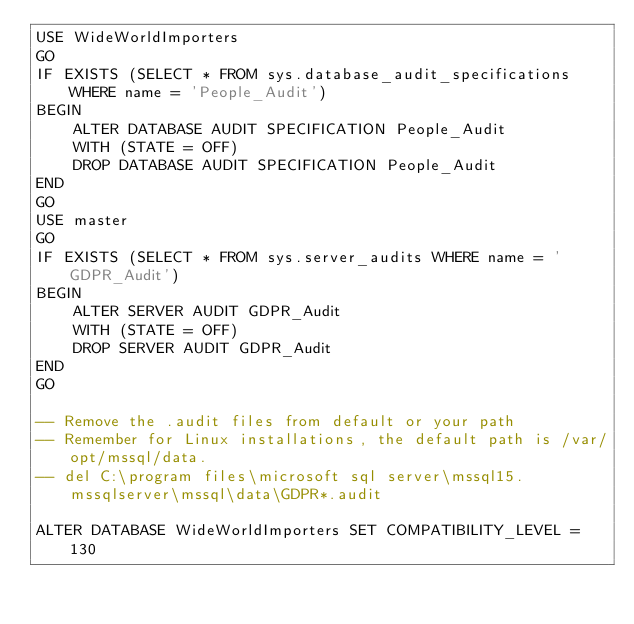<code> <loc_0><loc_0><loc_500><loc_500><_SQL_>USE WideWorldImporters
GO
IF EXISTS (SELECT * FROM sys.database_audit_specifications WHERE name = 'People_Audit')
BEGIN
	ALTER DATABASE AUDIT SPECIFICATION People_Audit 
	WITH (STATE = OFF)
	DROP DATABASE AUDIT SPECIFICATION People_Audit
END
GO
USE master
GO
IF EXISTS (SELECT * FROM sys.server_audits WHERE name = 'GDPR_Audit')
BEGIN
	ALTER SERVER AUDIT GDPR_Audit
	WITH (STATE = OFF)
	DROP SERVER AUDIT GDPR_Audit
END
GO

-- Remove the .audit files from default or your path
-- Remember for Linux installations, the default path is /var/opt/mssql/data.
-- del C:\program files\microsoft sql server\mssql15.mssqlserver\mssql\data\GDPR*.audit

ALTER DATABASE WideWorldImporters SET COMPATIBILITY_LEVEL = 130</code> 